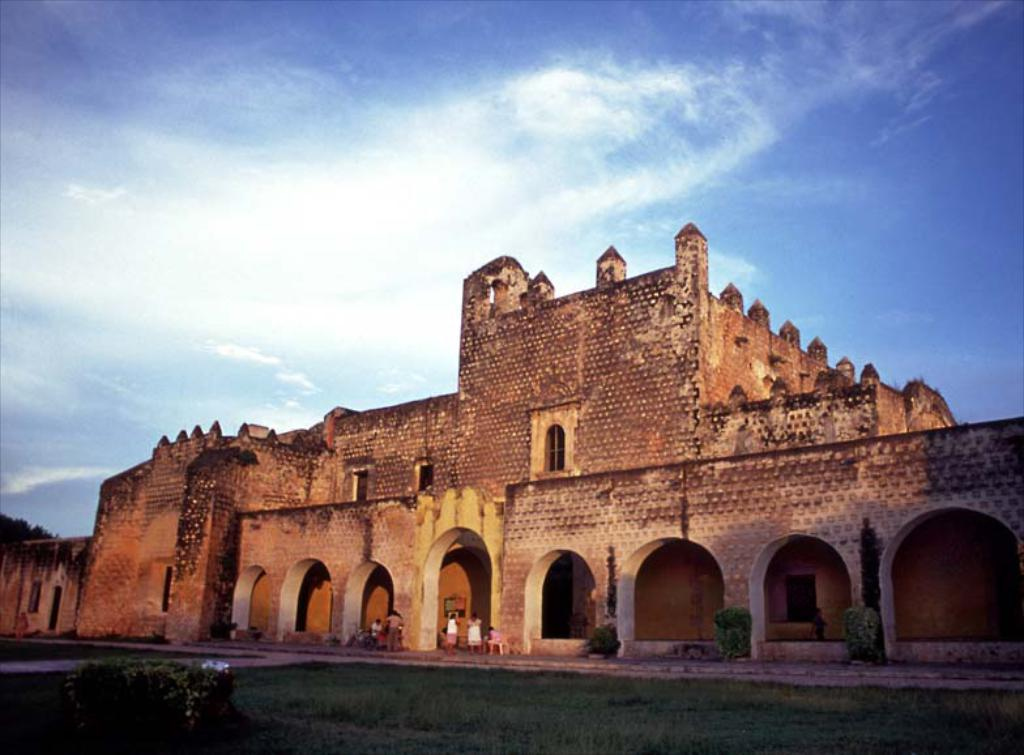What type of natural environment is present in the image? There is grass and plants in the image. What type of structure is visible in the image? There is a building in the image. Can you describe the people visible in the image? There are people visible in the image. What is the condition of the sky in the background of the image? The sky is clear in the background of the image. Where is the baby playing with the stamp in the wilderness? There is no baby or stamp present in the image, and the image does not depict a wilderness setting. 